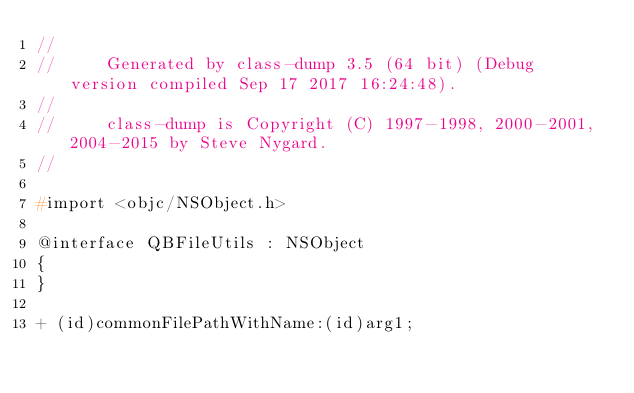<code> <loc_0><loc_0><loc_500><loc_500><_C_>//
//     Generated by class-dump 3.5 (64 bit) (Debug version compiled Sep 17 2017 16:24:48).
//
//     class-dump is Copyright (C) 1997-1998, 2000-2001, 2004-2015 by Steve Nygard.
//

#import <objc/NSObject.h>

@interface QBFileUtils : NSObject
{
}

+ (id)commonFilePathWithName:(id)arg1;</code> 